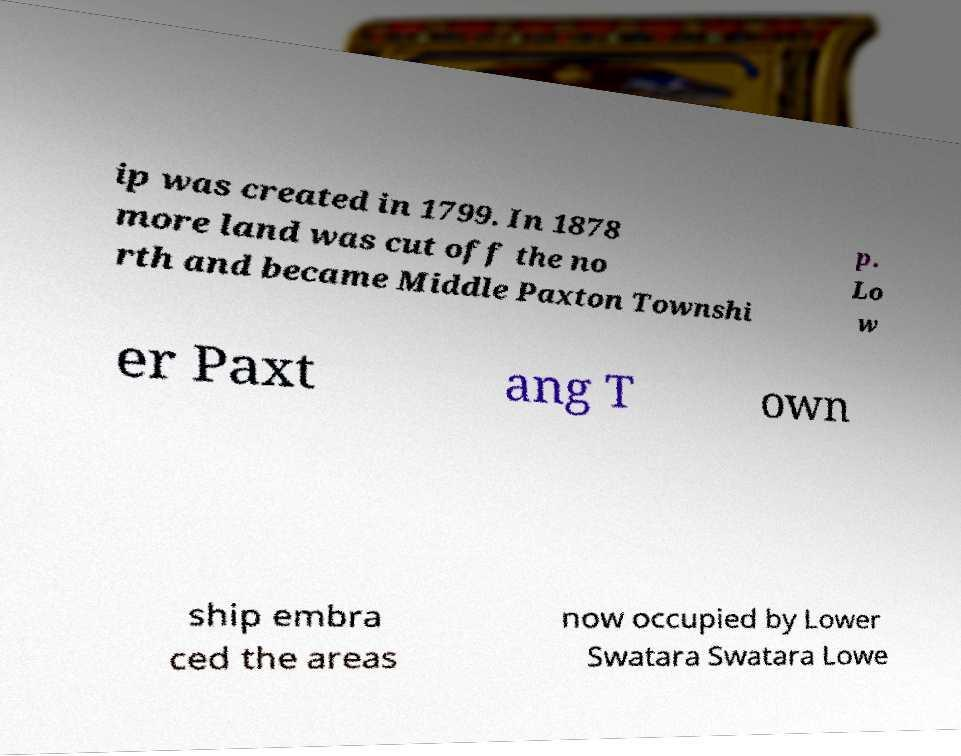Can you read and provide the text displayed in the image?This photo seems to have some interesting text. Can you extract and type it out for me? ip was created in 1799. In 1878 more land was cut off the no rth and became Middle Paxton Townshi p. Lo w er Paxt ang T own ship embra ced the areas now occupied by Lower Swatara Swatara Lowe 